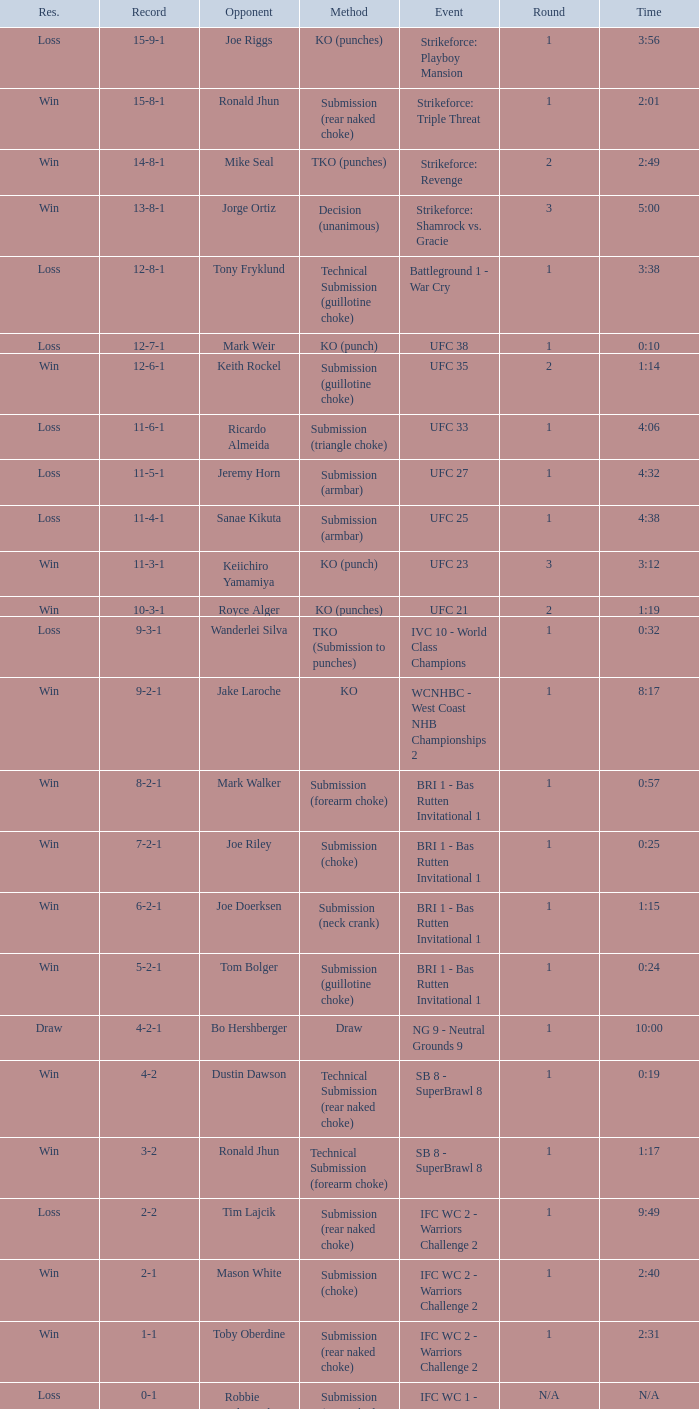Who was the opponent when the fight had a time of 0:10? Mark Weir. 